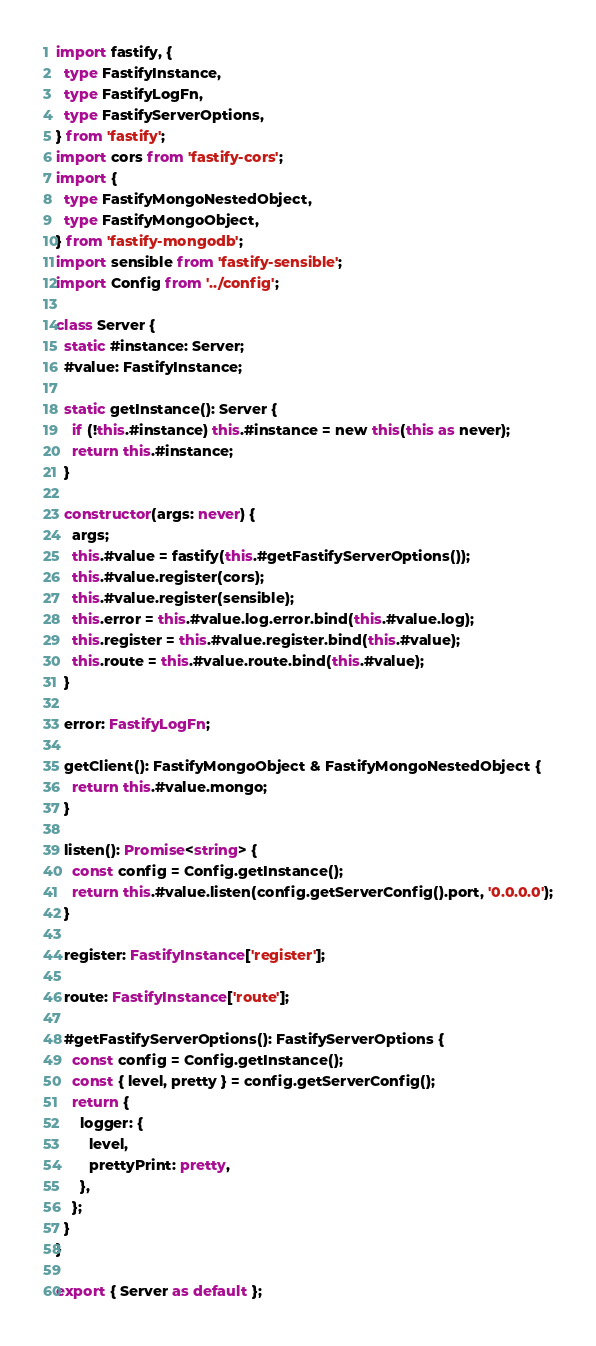<code> <loc_0><loc_0><loc_500><loc_500><_TypeScript_>import fastify, {
  type FastifyInstance,
  type FastifyLogFn,
  type FastifyServerOptions,
} from 'fastify';
import cors from 'fastify-cors';
import {
  type FastifyMongoNestedObject,
  type FastifyMongoObject,
} from 'fastify-mongodb';
import sensible from 'fastify-sensible';
import Config from '../config';

class Server {
  static #instance: Server;
  #value: FastifyInstance;

  static getInstance(): Server {
    if (!this.#instance) this.#instance = new this(this as never);
    return this.#instance;
  }

  constructor(args: never) {
    args;
    this.#value = fastify(this.#getFastifyServerOptions());
    this.#value.register(cors);
    this.#value.register(sensible);
    this.error = this.#value.log.error.bind(this.#value.log);
    this.register = this.#value.register.bind(this.#value);
    this.route = this.#value.route.bind(this.#value);
  }

  error: FastifyLogFn;

  getClient(): FastifyMongoObject & FastifyMongoNestedObject {
    return this.#value.mongo;
  }

  listen(): Promise<string> {
    const config = Config.getInstance();
    return this.#value.listen(config.getServerConfig().port, '0.0.0.0');
  }

  register: FastifyInstance['register'];

  route: FastifyInstance['route'];

  #getFastifyServerOptions(): FastifyServerOptions {
    const config = Config.getInstance();
    const { level, pretty } = config.getServerConfig();
    return {
      logger: {
        level,
        prettyPrint: pretty,
      },
    };
  }
}

export { Server as default };
</code> 